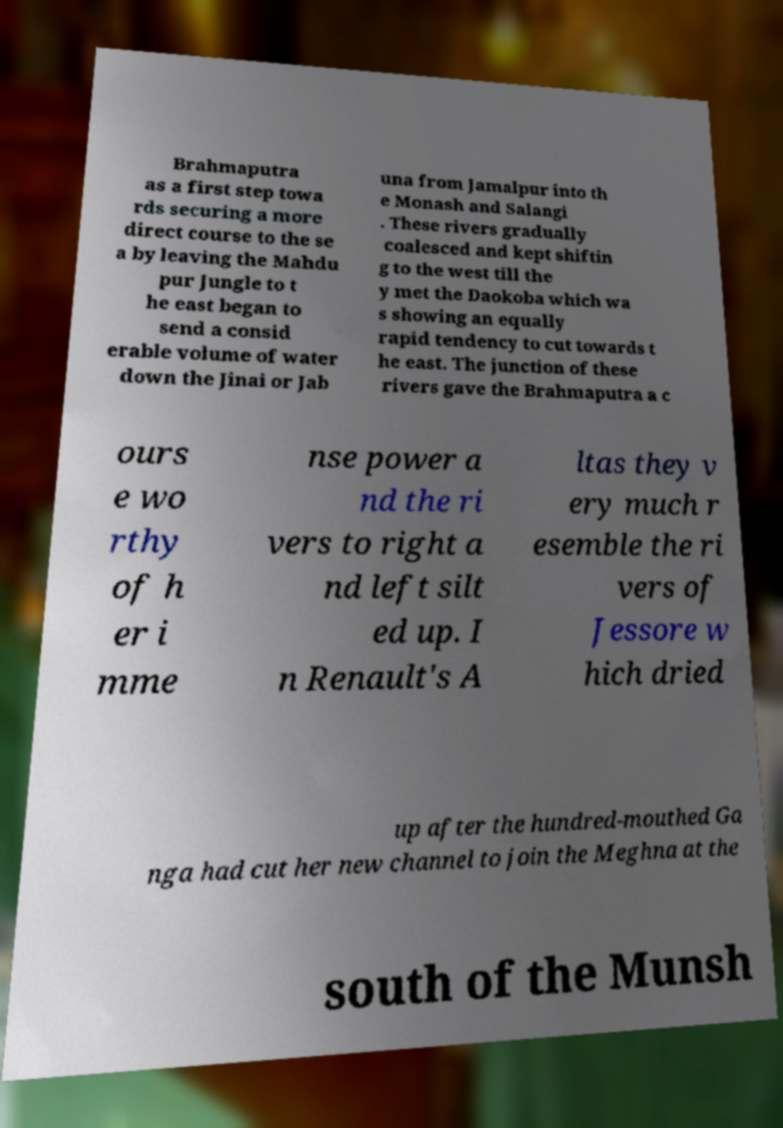Could you assist in decoding the text presented in this image and type it out clearly? Brahmaputra as a first step towa rds securing a more direct course to the se a by leaving the Mahdu pur Jungle to t he east began to send a consid erable volume of water down the Jinai or Jab una from Jamalpur into th e Monash and Salangi . These rivers gradually coalesced and kept shiftin g to the west till the y met the Daokoba which wa s showing an equally rapid tendency to cut towards t he east. The junction of these rivers gave the Brahmaputra a c ours e wo rthy of h er i mme nse power a nd the ri vers to right a nd left silt ed up. I n Renault's A ltas they v ery much r esemble the ri vers of Jessore w hich dried up after the hundred-mouthed Ga nga had cut her new channel to join the Meghna at the south of the Munsh 